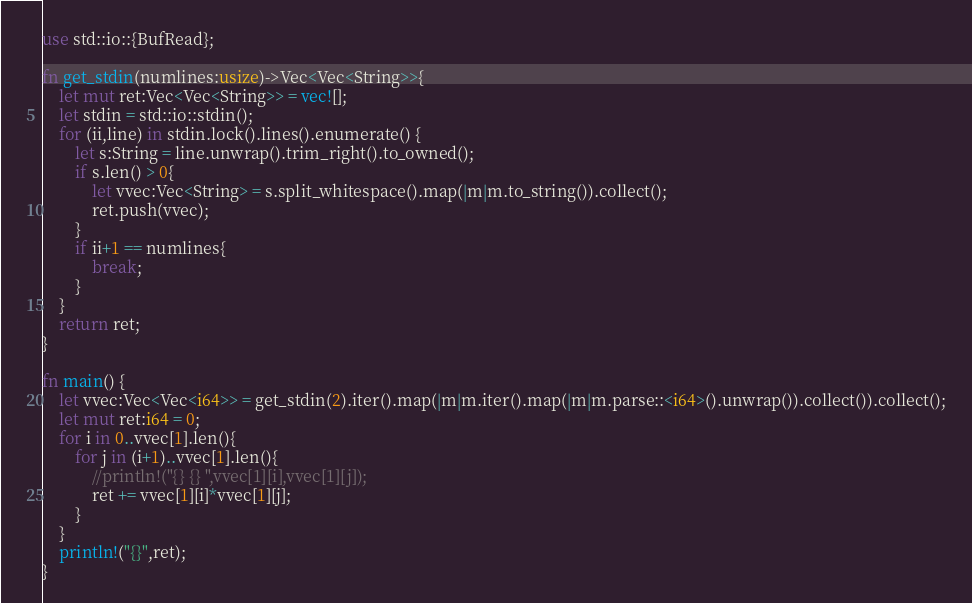<code> <loc_0><loc_0><loc_500><loc_500><_Rust_>
use std::io::{BufRead};

fn get_stdin(numlines:usize)->Vec<Vec<String>>{
    let mut ret:Vec<Vec<String>> = vec![];
    let stdin = std::io::stdin();
    for (ii,line) in stdin.lock().lines().enumerate() {
        let s:String = line.unwrap().trim_right().to_owned();
        if s.len() > 0{
            let vvec:Vec<String> = s.split_whitespace().map(|m|m.to_string()).collect();
            ret.push(vvec);
        }
        if ii+1 == numlines{
            break;
        }
    }
    return ret;
}

fn main() {
    let vvec:Vec<Vec<i64>> = get_stdin(2).iter().map(|m|m.iter().map(|m|m.parse::<i64>().unwrap()).collect()).collect();
    let mut ret:i64 = 0;
    for i in 0..vvec[1].len(){
        for j in (i+1)..vvec[1].len(){
       		//println!("{} {} ",vvec[1][i],vvec[1][j]);
            ret += vvec[1][i]*vvec[1][j];
        }
    }
    println!("{}",ret);
}
</code> 